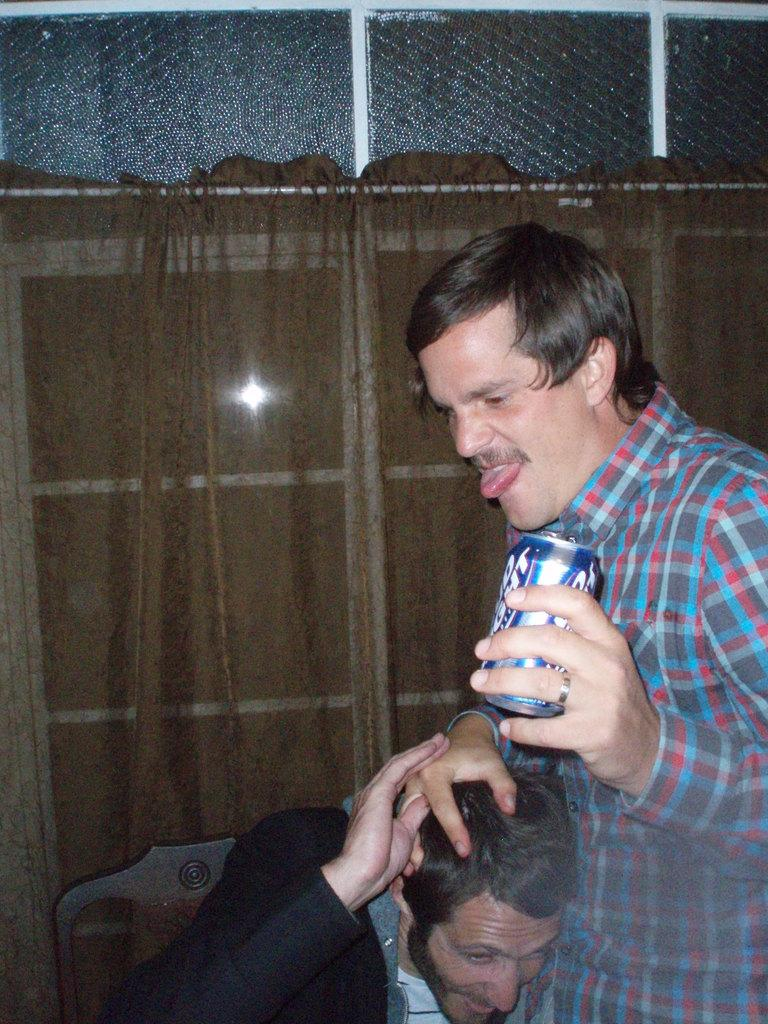What is the man in the image wearing? There is a man wearing a black suit in the image. What object is the other man holding in the image? There is a man with a coke tin in the image. What type of window can be seen in the background of the image? There is a glass window in the background of the image. What color is the curtain in the background of the image? There is a brown color curtain in the background of the image. What type of nail is the man using to hang the twig in the image? There is no nail or twig present in the image. 